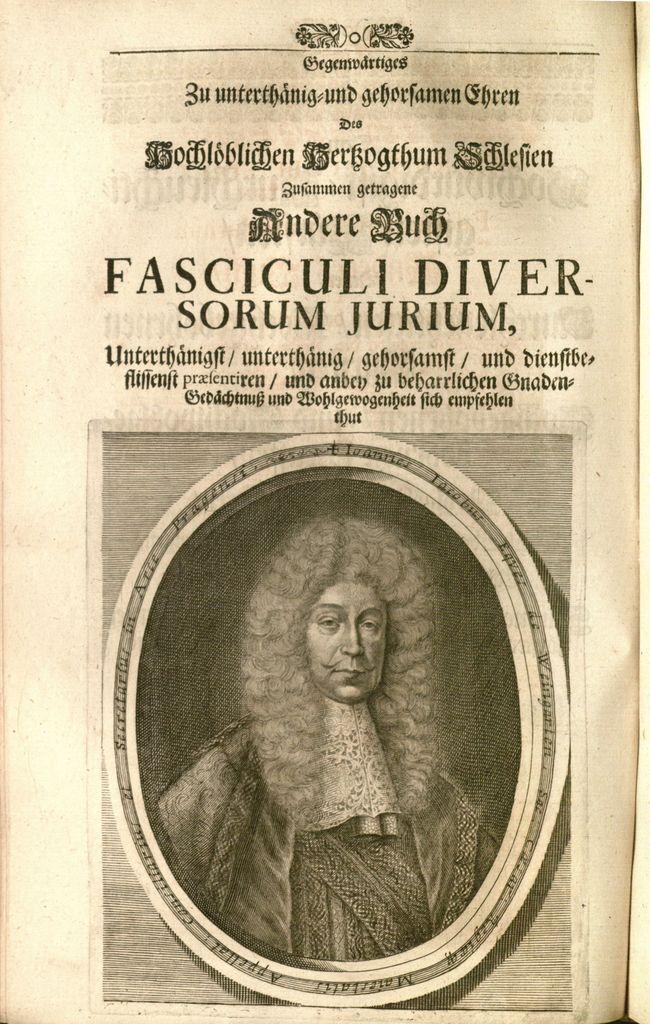Describe this image in one or two sentences. In this image I can see depiction of a person and here I can see something is written. 